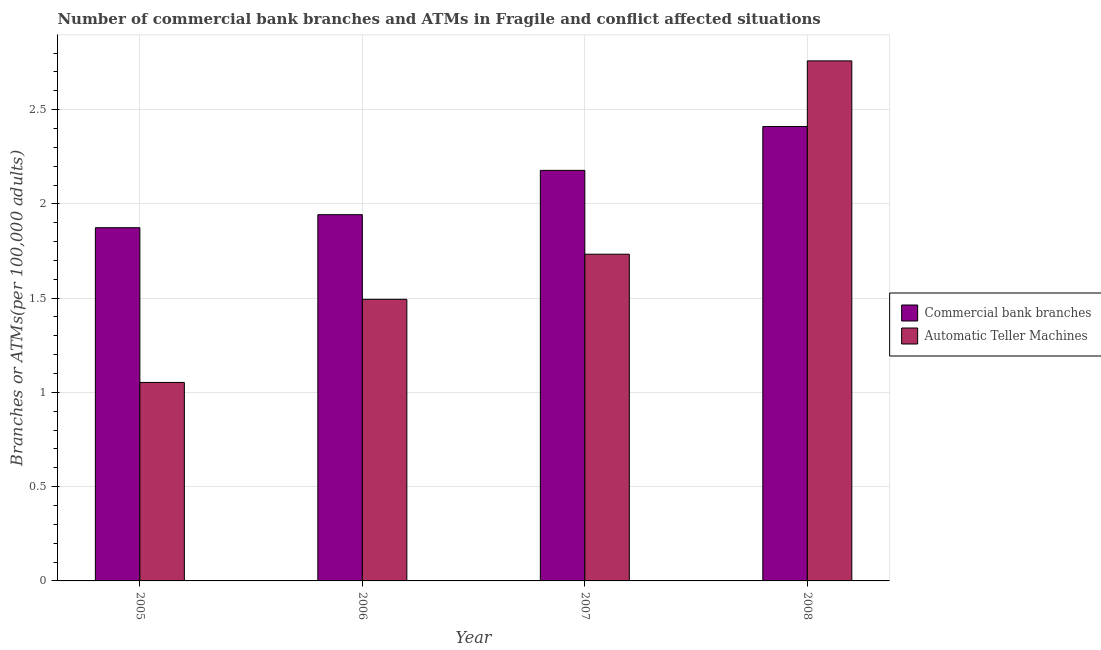How many groups of bars are there?
Give a very brief answer. 4. How many bars are there on the 2nd tick from the right?
Keep it short and to the point. 2. In how many cases, is the number of bars for a given year not equal to the number of legend labels?
Give a very brief answer. 0. What is the number of commercal bank branches in 2006?
Your response must be concise. 1.94. Across all years, what is the maximum number of commercal bank branches?
Give a very brief answer. 2.41. Across all years, what is the minimum number of atms?
Give a very brief answer. 1.05. In which year was the number of commercal bank branches maximum?
Give a very brief answer. 2008. In which year was the number of atms minimum?
Provide a short and direct response. 2005. What is the total number of commercal bank branches in the graph?
Give a very brief answer. 8.4. What is the difference between the number of commercal bank branches in 2006 and that in 2007?
Give a very brief answer. -0.23. What is the difference between the number of atms in 2008 and the number of commercal bank branches in 2006?
Your answer should be very brief. 1.26. What is the average number of atms per year?
Your answer should be compact. 1.76. What is the ratio of the number of atms in 2005 to that in 2007?
Provide a short and direct response. 0.61. Is the number of atms in 2006 less than that in 2008?
Give a very brief answer. Yes. Is the difference between the number of atms in 2007 and 2008 greater than the difference between the number of commercal bank branches in 2007 and 2008?
Your answer should be compact. No. What is the difference between the highest and the second highest number of commercal bank branches?
Provide a succinct answer. 0.23. What is the difference between the highest and the lowest number of commercal bank branches?
Make the answer very short. 0.54. In how many years, is the number of commercal bank branches greater than the average number of commercal bank branches taken over all years?
Keep it short and to the point. 2. What does the 2nd bar from the left in 2006 represents?
Provide a succinct answer. Automatic Teller Machines. What does the 2nd bar from the right in 2005 represents?
Your answer should be very brief. Commercial bank branches. How many bars are there?
Your answer should be very brief. 8. How many years are there in the graph?
Provide a short and direct response. 4. What is the difference between two consecutive major ticks on the Y-axis?
Offer a terse response. 0.5. Does the graph contain any zero values?
Keep it short and to the point. No. Does the graph contain grids?
Give a very brief answer. Yes. Where does the legend appear in the graph?
Your answer should be very brief. Center right. How are the legend labels stacked?
Offer a very short reply. Vertical. What is the title of the graph?
Provide a short and direct response. Number of commercial bank branches and ATMs in Fragile and conflict affected situations. What is the label or title of the X-axis?
Your answer should be compact. Year. What is the label or title of the Y-axis?
Your response must be concise. Branches or ATMs(per 100,0 adults). What is the Branches or ATMs(per 100,000 adults) of Commercial bank branches in 2005?
Provide a short and direct response. 1.87. What is the Branches or ATMs(per 100,000 adults) in Automatic Teller Machines in 2005?
Your response must be concise. 1.05. What is the Branches or ATMs(per 100,000 adults) in Commercial bank branches in 2006?
Offer a very short reply. 1.94. What is the Branches or ATMs(per 100,000 adults) of Automatic Teller Machines in 2006?
Offer a terse response. 1.49. What is the Branches or ATMs(per 100,000 adults) of Commercial bank branches in 2007?
Make the answer very short. 2.18. What is the Branches or ATMs(per 100,000 adults) of Automatic Teller Machines in 2007?
Ensure brevity in your answer.  1.73. What is the Branches or ATMs(per 100,000 adults) of Commercial bank branches in 2008?
Provide a succinct answer. 2.41. What is the Branches or ATMs(per 100,000 adults) of Automatic Teller Machines in 2008?
Your response must be concise. 2.76. Across all years, what is the maximum Branches or ATMs(per 100,000 adults) of Commercial bank branches?
Offer a terse response. 2.41. Across all years, what is the maximum Branches or ATMs(per 100,000 adults) in Automatic Teller Machines?
Ensure brevity in your answer.  2.76. Across all years, what is the minimum Branches or ATMs(per 100,000 adults) in Commercial bank branches?
Offer a very short reply. 1.87. Across all years, what is the minimum Branches or ATMs(per 100,000 adults) in Automatic Teller Machines?
Your answer should be very brief. 1.05. What is the total Branches or ATMs(per 100,000 adults) in Commercial bank branches in the graph?
Offer a very short reply. 8.4. What is the total Branches or ATMs(per 100,000 adults) of Automatic Teller Machines in the graph?
Your response must be concise. 7.04. What is the difference between the Branches or ATMs(per 100,000 adults) in Commercial bank branches in 2005 and that in 2006?
Make the answer very short. -0.07. What is the difference between the Branches or ATMs(per 100,000 adults) in Automatic Teller Machines in 2005 and that in 2006?
Provide a short and direct response. -0.44. What is the difference between the Branches or ATMs(per 100,000 adults) in Commercial bank branches in 2005 and that in 2007?
Provide a succinct answer. -0.3. What is the difference between the Branches or ATMs(per 100,000 adults) of Automatic Teller Machines in 2005 and that in 2007?
Offer a very short reply. -0.68. What is the difference between the Branches or ATMs(per 100,000 adults) of Commercial bank branches in 2005 and that in 2008?
Offer a very short reply. -0.54. What is the difference between the Branches or ATMs(per 100,000 adults) in Automatic Teller Machines in 2005 and that in 2008?
Offer a terse response. -1.71. What is the difference between the Branches or ATMs(per 100,000 adults) in Commercial bank branches in 2006 and that in 2007?
Make the answer very short. -0.23. What is the difference between the Branches or ATMs(per 100,000 adults) in Automatic Teller Machines in 2006 and that in 2007?
Make the answer very short. -0.24. What is the difference between the Branches or ATMs(per 100,000 adults) of Commercial bank branches in 2006 and that in 2008?
Keep it short and to the point. -0.47. What is the difference between the Branches or ATMs(per 100,000 adults) in Automatic Teller Machines in 2006 and that in 2008?
Your answer should be very brief. -1.26. What is the difference between the Branches or ATMs(per 100,000 adults) of Commercial bank branches in 2007 and that in 2008?
Give a very brief answer. -0.23. What is the difference between the Branches or ATMs(per 100,000 adults) in Automatic Teller Machines in 2007 and that in 2008?
Offer a terse response. -1.03. What is the difference between the Branches or ATMs(per 100,000 adults) of Commercial bank branches in 2005 and the Branches or ATMs(per 100,000 adults) of Automatic Teller Machines in 2006?
Make the answer very short. 0.38. What is the difference between the Branches or ATMs(per 100,000 adults) of Commercial bank branches in 2005 and the Branches or ATMs(per 100,000 adults) of Automatic Teller Machines in 2007?
Your response must be concise. 0.14. What is the difference between the Branches or ATMs(per 100,000 adults) of Commercial bank branches in 2005 and the Branches or ATMs(per 100,000 adults) of Automatic Teller Machines in 2008?
Ensure brevity in your answer.  -0.89. What is the difference between the Branches or ATMs(per 100,000 adults) in Commercial bank branches in 2006 and the Branches or ATMs(per 100,000 adults) in Automatic Teller Machines in 2007?
Your answer should be compact. 0.21. What is the difference between the Branches or ATMs(per 100,000 adults) in Commercial bank branches in 2006 and the Branches or ATMs(per 100,000 adults) in Automatic Teller Machines in 2008?
Provide a short and direct response. -0.82. What is the difference between the Branches or ATMs(per 100,000 adults) in Commercial bank branches in 2007 and the Branches or ATMs(per 100,000 adults) in Automatic Teller Machines in 2008?
Offer a very short reply. -0.58. What is the average Branches or ATMs(per 100,000 adults) of Commercial bank branches per year?
Offer a terse response. 2.1. What is the average Branches or ATMs(per 100,000 adults) in Automatic Teller Machines per year?
Keep it short and to the point. 1.76. In the year 2005, what is the difference between the Branches or ATMs(per 100,000 adults) of Commercial bank branches and Branches or ATMs(per 100,000 adults) of Automatic Teller Machines?
Provide a short and direct response. 0.82. In the year 2006, what is the difference between the Branches or ATMs(per 100,000 adults) of Commercial bank branches and Branches or ATMs(per 100,000 adults) of Automatic Teller Machines?
Ensure brevity in your answer.  0.45. In the year 2007, what is the difference between the Branches or ATMs(per 100,000 adults) of Commercial bank branches and Branches or ATMs(per 100,000 adults) of Automatic Teller Machines?
Provide a short and direct response. 0.44. In the year 2008, what is the difference between the Branches or ATMs(per 100,000 adults) of Commercial bank branches and Branches or ATMs(per 100,000 adults) of Automatic Teller Machines?
Your answer should be compact. -0.35. What is the ratio of the Branches or ATMs(per 100,000 adults) in Commercial bank branches in 2005 to that in 2006?
Ensure brevity in your answer.  0.96. What is the ratio of the Branches or ATMs(per 100,000 adults) of Automatic Teller Machines in 2005 to that in 2006?
Your response must be concise. 0.7. What is the ratio of the Branches or ATMs(per 100,000 adults) in Commercial bank branches in 2005 to that in 2007?
Keep it short and to the point. 0.86. What is the ratio of the Branches or ATMs(per 100,000 adults) in Automatic Teller Machines in 2005 to that in 2007?
Ensure brevity in your answer.  0.61. What is the ratio of the Branches or ATMs(per 100,000 adults) in Commercial bank branches in 2005 to that in 2008?
Your response must be concise. 0.78. What is the ratio of the Branches or ATMs(per 100,000 adults) of Automatic Teller Machines in 2005 to that in 2008?
Offer a terse response. 0.38. What is the ratio of the Branches or ATMs(per 100,000 adults) of Commercial bank branches in 2006 to that in 2007?
Keep it short and to the point. 0.89. What is the ratio of the Branches or ATMs(per 100,000 adults) in Automatic Teller Machines in 2006 to that in 2007?
Offer a terse response. 0.86. What is the ratio of the Branches or ATMs(per 100,000 adults) in Commercial bank branches in 2006 to that in 2008?
Offer a terse response. 0.81. What is the ratio of the Branches or ATMs(per 100,000 adults) in Automatic Teller Machines in 2006 to that in 2008?
Make the answer very short. 0.54. What is the ratio of the Branches or ATMs(per 100,000 adults) in Commercial bank branches in 2007 to that in 2008?
Your answer should be very brief. 0.9. What is the ratio of the Branches or ATMs(per 100,000 adults) of Automatic Teller Machines in 2007 to that in 2008?
Offer a very short reply. 0.63. What is the difference between the highest and the second highest Branches or ATMs(per 100,000 adults) in Commercial bank branches?
Ensure brevity in your answer.  0.23. What is the difference between the highest and the second highest Branches or ATMs(per 100,000 adults) in Automatic Teller Machines?
Give a very brief answer. 1.03. What is the difference between the highest and the lowest Branches or ATMs(per 100,000 adults) in Commercial bank branches?
Your answer should be compact. 0.54. What is the difference between the highest and the lowest Branches or ATMs(per 100,000 adults) in Automatic Teller Machines?
Offer a very short reply. 1.71. 